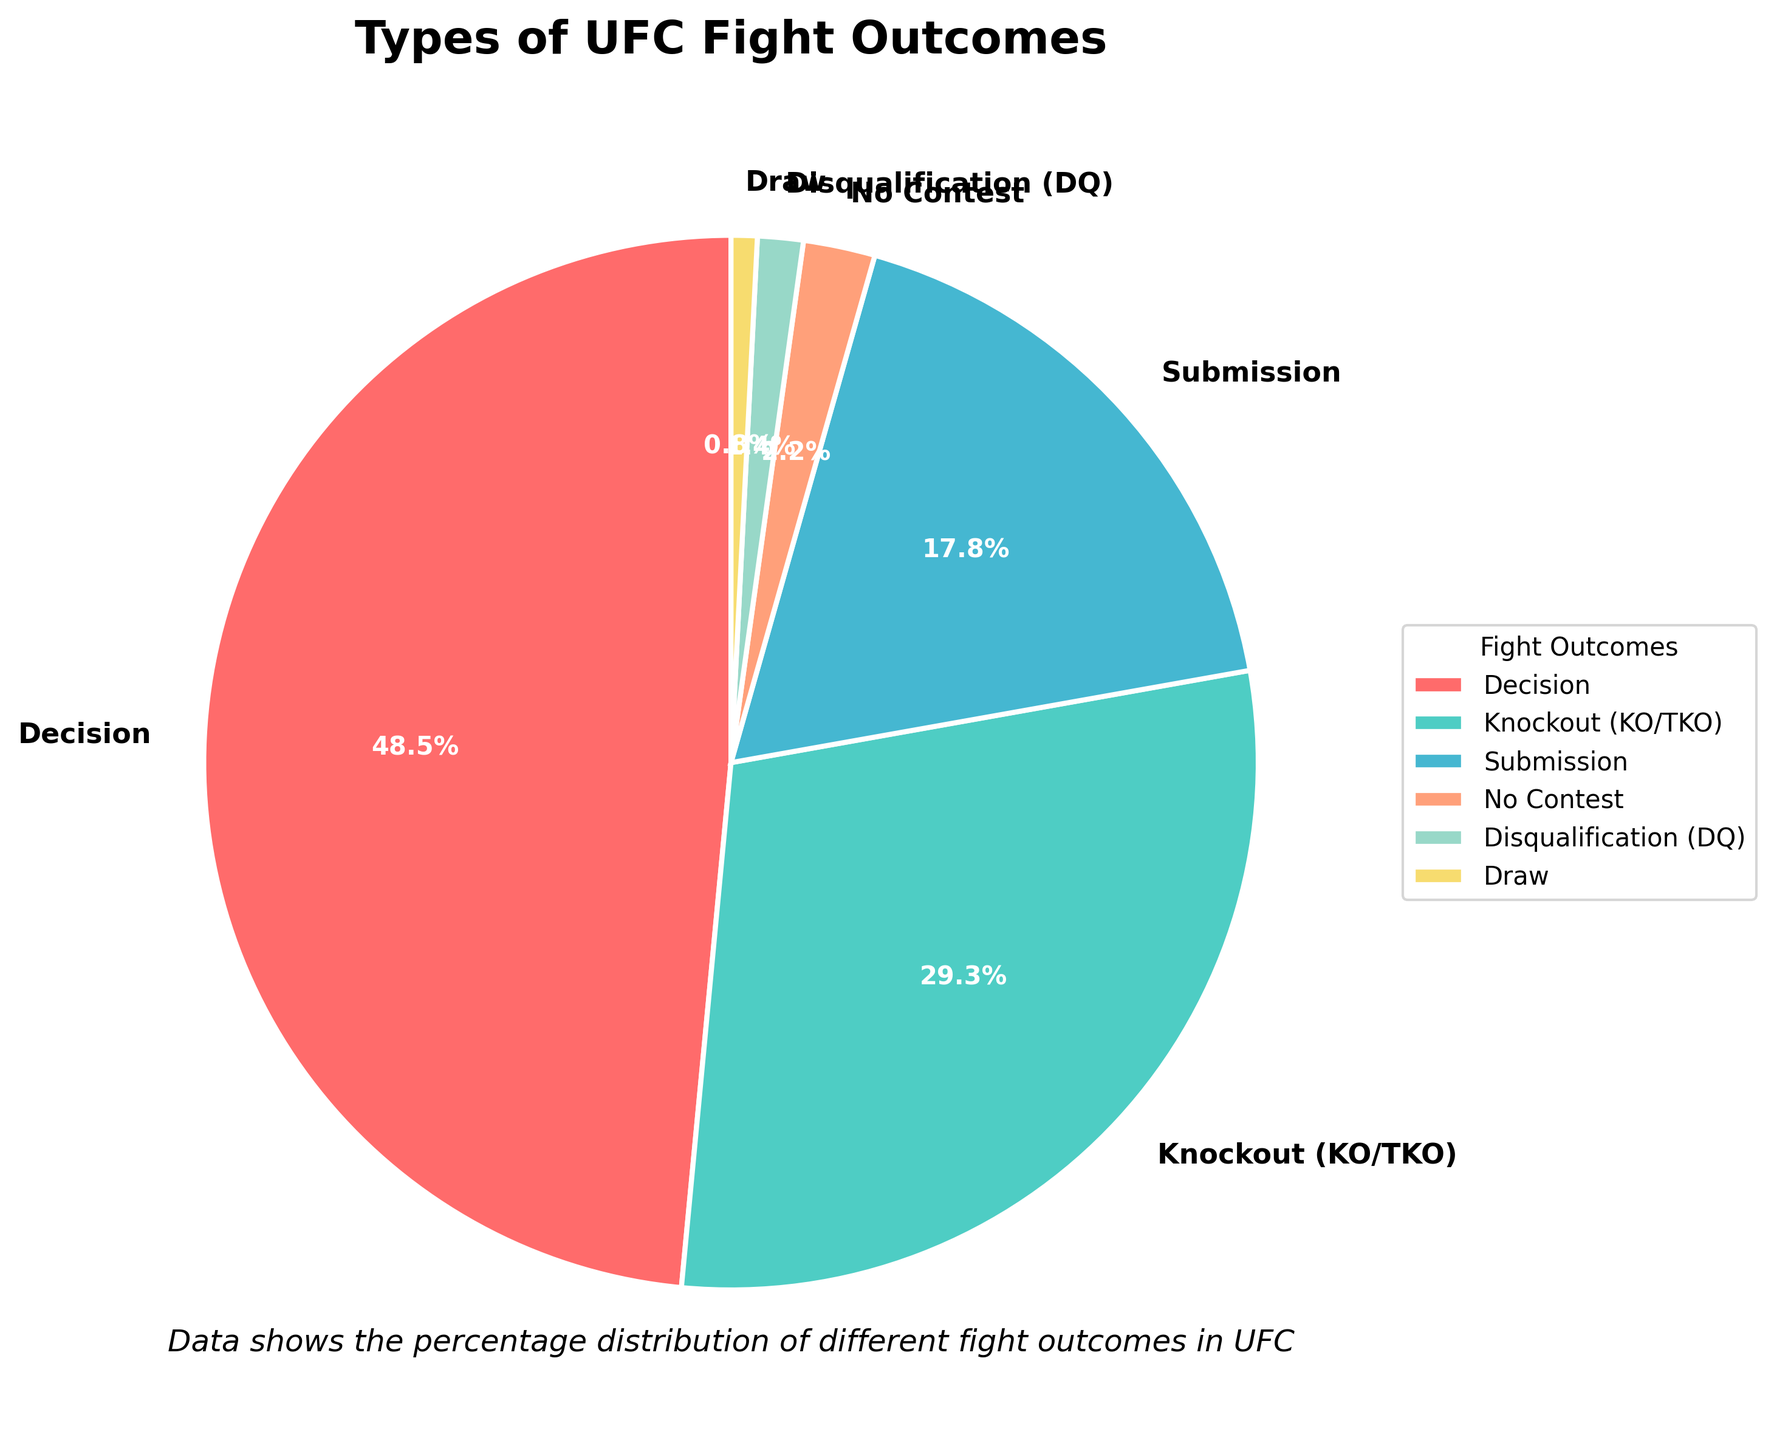What is the most common type of UFC fight outcome? According to the pie chart, the largest segment is labeled "Decision," which indicates it has the highest percentage among all outcomes.
Answer: Decision Which two fight outcomes together make up more than half of the total outcomes? The pie chart shows the percentages of "Decision" (48.5%) and "Knockout (KO/TKO)" (29.3%). Adding these together gives 77.8%, which is more than half.
Answer: Decision and Knockout (KO/TKO) What percentage of fights end in a submission? The segment labeled "Submission" in the pie chart shows the percentage.
Answer: 17.8% Which outcome is more frequent, a No Contest or a Draw? The pie chart shows the "No Contest" segment at 2.2%, while the "Draw" segment is at 0.8%. Therefore, No Contest is more frequent.
Answer: No Contest How much less common is a Disqualification compared to a Submission? The pie chart indicates a "Disqualification (DQ)" percentage of 1.4% and "Submission" at 17.8%. Subtracting these, 17.8% - 1.4% = 16.4%.
Answer: 16.4% Which color represents Knockout (KO/TKO) outcomes? The pie chart uses specific colors for each segment. The Knockout (KO/TKO) outcome is represented by the green segment.
Answer: Green If you sum the percentages of the three least common outcomes, what is the total? The three least common outcomes are "Draw" (0.8%), "Disqualification (DQ)" (1.4%), and "No Contest" (2.2%). Adding these gives 0.8% + 1.4% + 2.2% = 4.4%.
Answer: 4.4% Are there more fights that end in a Decision or in a Knockout (KO/TKO) and Submission combined? The Decision outcome is 48.5%, while the combined percentage of Knockout (KO/TKO) and Submission is 29.3% + 17.8% = 47.1%. Decision is more common.
Answer: Decision Is the cumulative percentage of Knockout (KO/TKO), Submission, and No Contest greater than 50%? Adding up the percentages for Knockout (KO/TKO) (29.3%), Submission (17.8%), and No Contest (2.2%), we get 29.3% + 17.8% + 2.2% = 49.3%, which is less than 50%.
Answer: No 